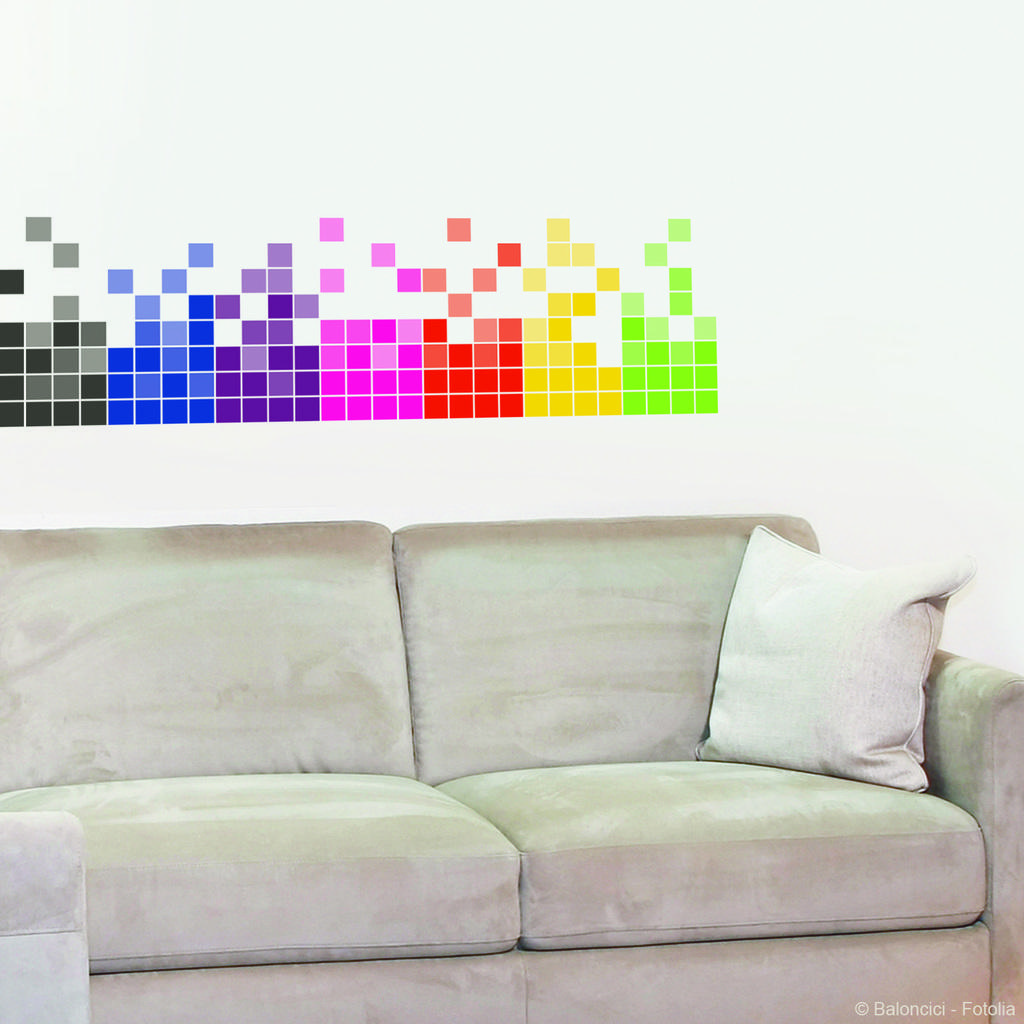What is the main subject of the image? The main subject of the image is a group of people sitting around a table. What are the people in the image doing? The people in the image are having a meal. Can you describe the setting of the image? The setting of the image is around a table. What type of fruit is being served on the channel in the image? There is no fruit or channel present in the image; it features a group of people sitting around a table having a meal. 